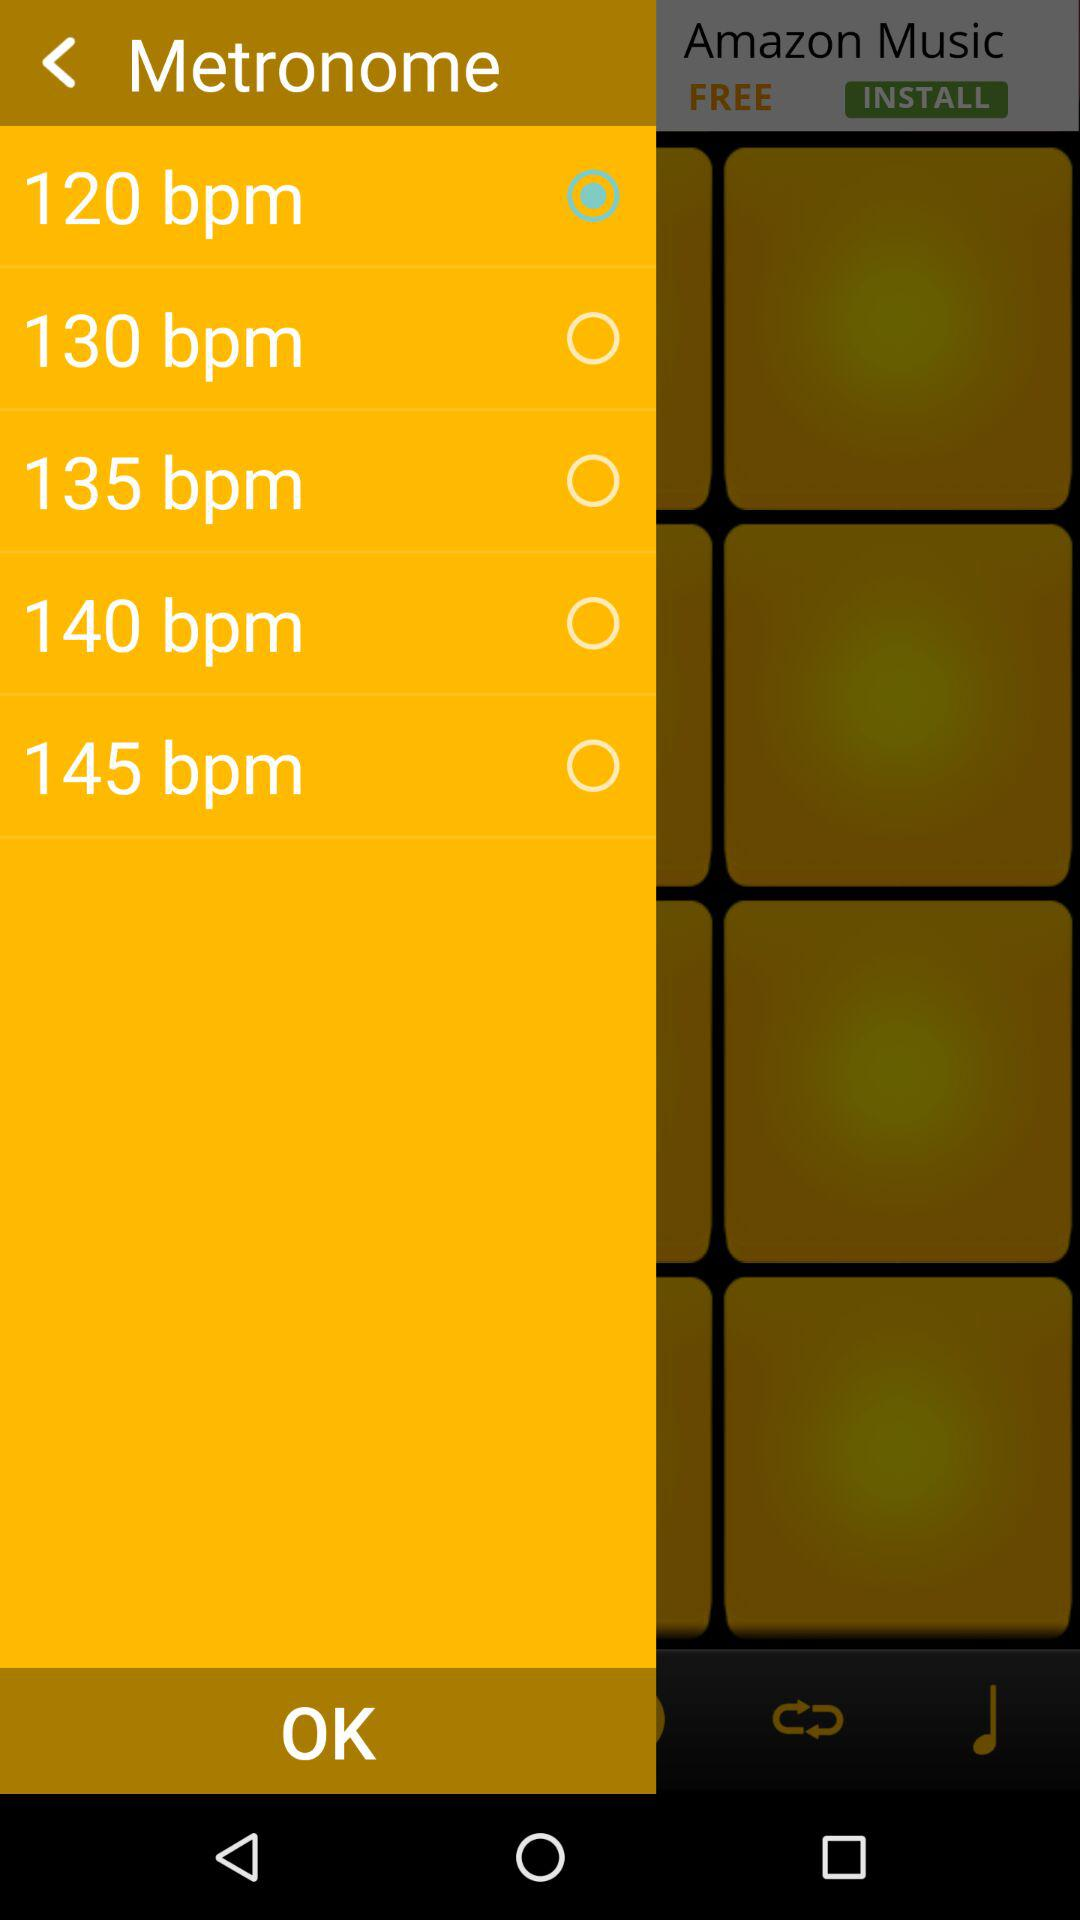Which option is selected in "Metronome"? The selected option in "Metronome" is "120 bpm". 